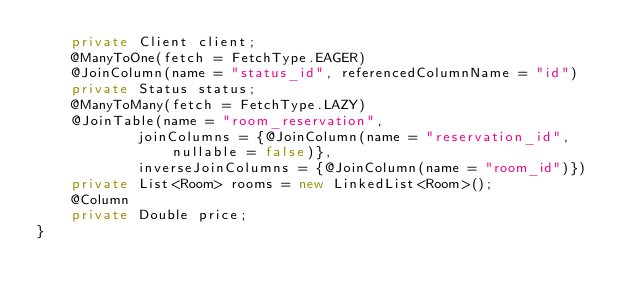Convert code to text. <code><loc_0><loc_0><loc_500><loc_500><_Java_>    private Client client;
    @ManyToOne(fetch = FetchType.EAGER)
    @JoinColumn(name = "status_id", referencedColumnName = "id")
    private Status status;
    @ManyToMany(fetch = FetchType.LAZY)
    @JoinTable(name = "room_reservation",
            joinColumns = {@JoinColumn(name = "reservation_id", nullable = false)},
            inverseJoinColumns = {@JoinColumn(name = "room_id")})
    private List<Room> rooms = new LinkedList<Room>();
    @Column
    private Double price;
}

</code> 